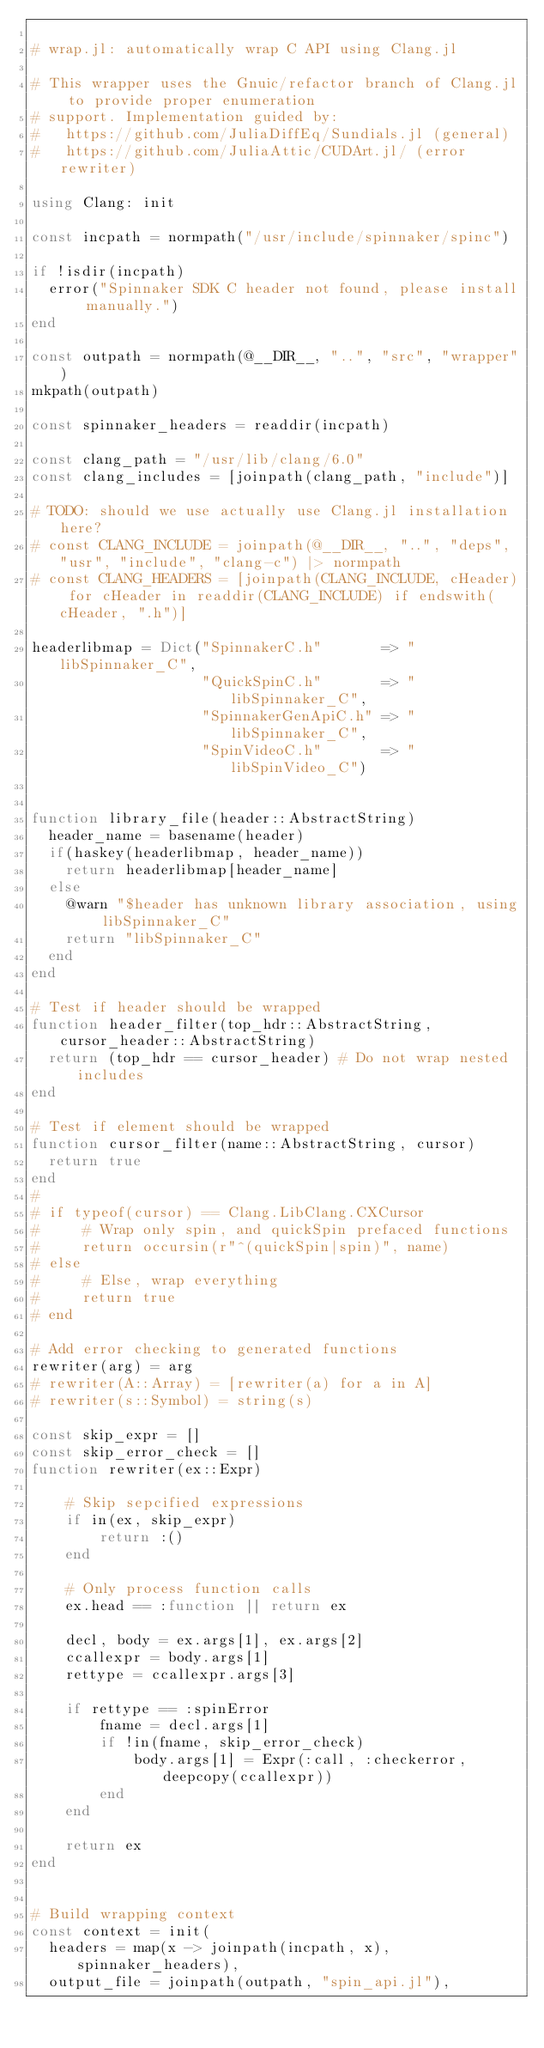Convert code to text. <code><loc_0><loc_0><loc_500><loc_500><_Julia_>
# wrap.jl: automatically wrap C API using Clang.jl

# This wrapper uses the Gnuic/refactor branch of Clang.jl to provide proper enumeration
# support. Implementation guided by:
#   https://github.com/JuliaDiffEq/Sundials.jl (general)
#   https://github.com/JuliaAttic/CUDArt.jl/ (error rewriter)

using Clang: init

const incpath = normpath("/usr/include/spinnaker/spinc")

if !isdir(incpath)
  error("Spinnaker SDK C header not found, please install manually.")
end

const outpath = normpath(@__DIR__, "..", "src", "wrapper")
mkpath(outpath)

const spinnaker_headers = readdir(incpath)

const clang_path = "/usr/lib/clang/6.0"
const clang_includes = [joinpath(clang_path, "include")]

# TODO: should we use actually use Clang.jl installation here?
# const CLANG_INCLUDE = joinpath(@__DIR__, "..", "deps", "usr", "include", "clang-c") |> normpath
# const CLANG_HEADERS = [joinpath(CLANG_INCLUDE, cHeader) for cHeader in readdir(CLANG_INCLUDE) if endswith(cHeader, ".h")]

headerlibmap = Dict("SpinnakerC.h"       => "libSpinnaker_C",
                    "QuickSpinC.h"       => "libSpinnaker_C",
                    "SpinnakerGenApiC.h" => "libSpinnaker_C",
                    "SpinVideoC.h"       => "libSpinVideo_C")


function library_file(header::AbstractString)
  header_name = basename(header)
  if(haskey(headerlibmap, header_name))
    return headerlibmap[header_name]
  else
    @warn "$header has unknown library association, using libSpinnaker_C"
    return "libSpinnaker_C"
  end
end

# Test if header should be wrapped
function header_filter(top_hdr::AbstractString, cursor_header::AbstractString)
  return (top_hdr == cursor_header) # Do not wrap nested includes
end

# Test if element should be wrapped
function cursor_filter(name::AbstractString, cursor)
  return true
end
#
# if typeof(cursor) == Clang.LibClang.CXCursor
#     # Wrap only spin, and quickSpin prefaced functions
#     return occursin(r"^(quickSpin|spin)", name)
# else
#     # Else, wrap everything
#     return true
# end

# Add error checking to generated functions
rewriter(arg) = arg
# rewriter(A::Array) = [rewriter(a) for a in A]
# rewriter(s::Symbol) = string(s)

const skip_expr = []
const skip_error_check = []
function rewriter(ex::Expr)

    # Skip sepcified expressions
    if in(ex, skip_expr)
        return :()
    end

    # Only process function calls
    ex.head == :function || return ex

    decl, body = ex.args[1], ex.args[2]
    ccallexpr = body.args[1]
    rettype = ccallexpr.args[3]

    if rettype == :spinError
        fname = decl.args[1]
        if !in(fname, skip_error_check)
            body.args[1] = Expr(:call, :checkerror, deepcopy(ccallexpr))
        end
    end

    return ex
end


# Build wrapping context
const context = init(
  headers = map(x -> joinpath(incpath, x), spinnaker_headers),
  output_file = joinpath(outpath, "spin_api.jl"),</code> 